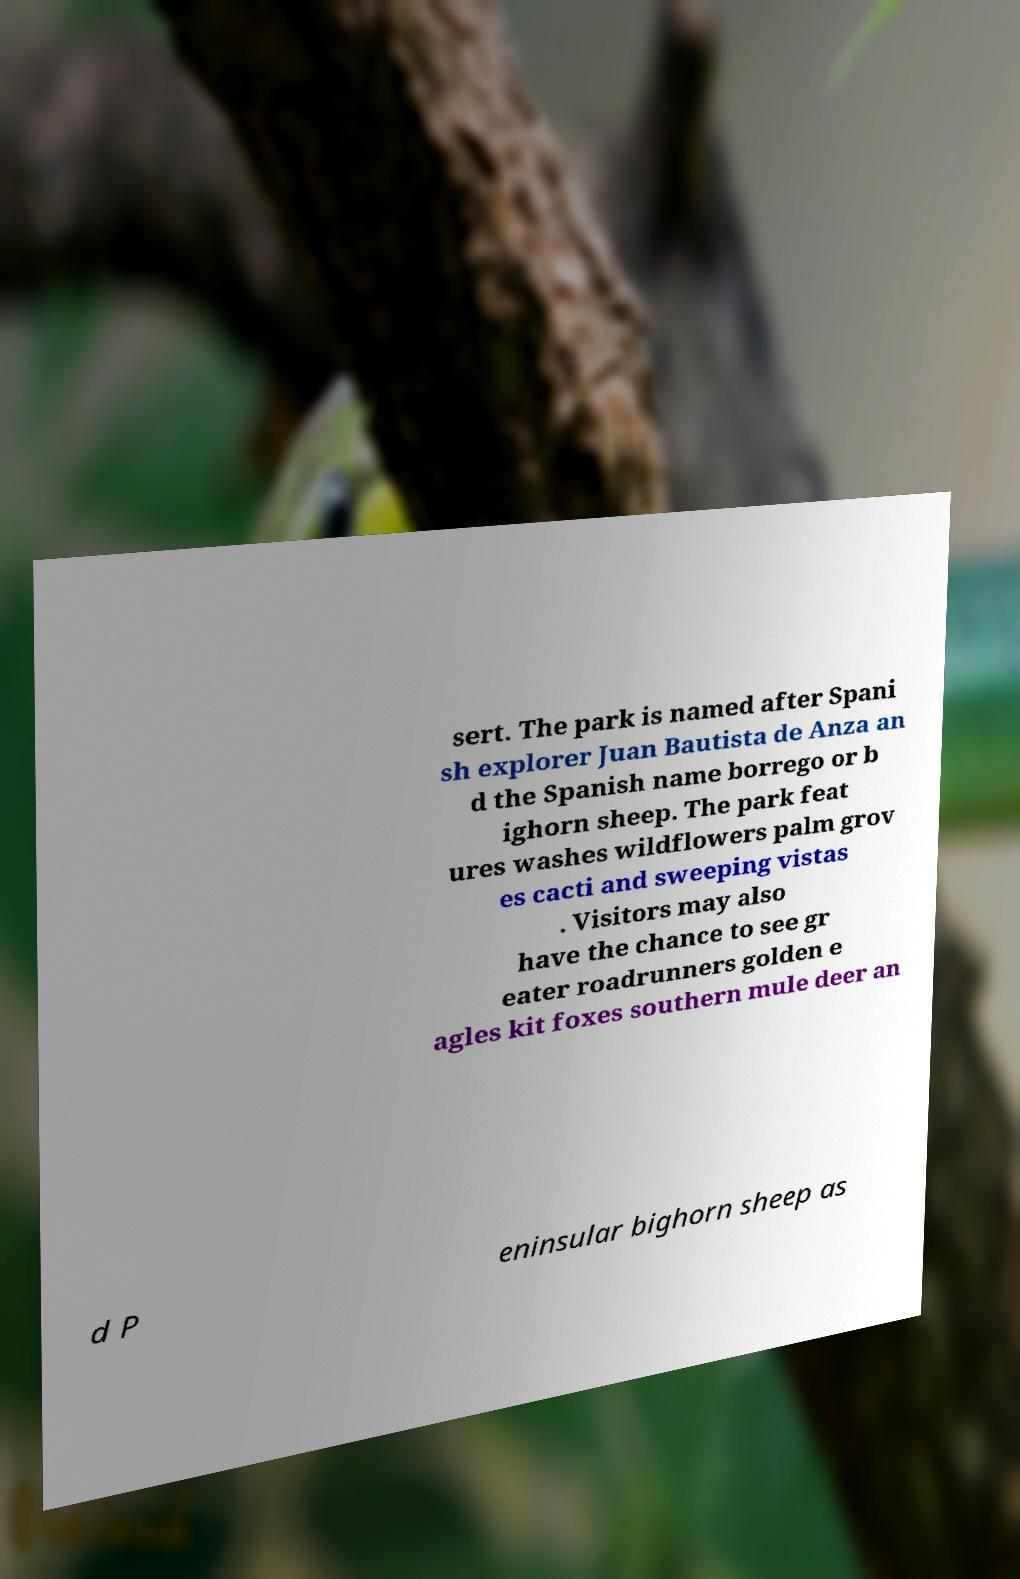What messages or text are displayed in this image? I need them in a readable, typed format. sert. The park is named after Spani sh explorer Juan Bautista de Anza an d the Spanish name borrego or b ighorn sheep. The park feat ures washes wildflowers palm grov es cacti and sweeping vistas . Visitors may also have the chance to see gr eater roadrunners golden e agles kit foxes southern mule deer an d P eninsular bighorn sheep as 